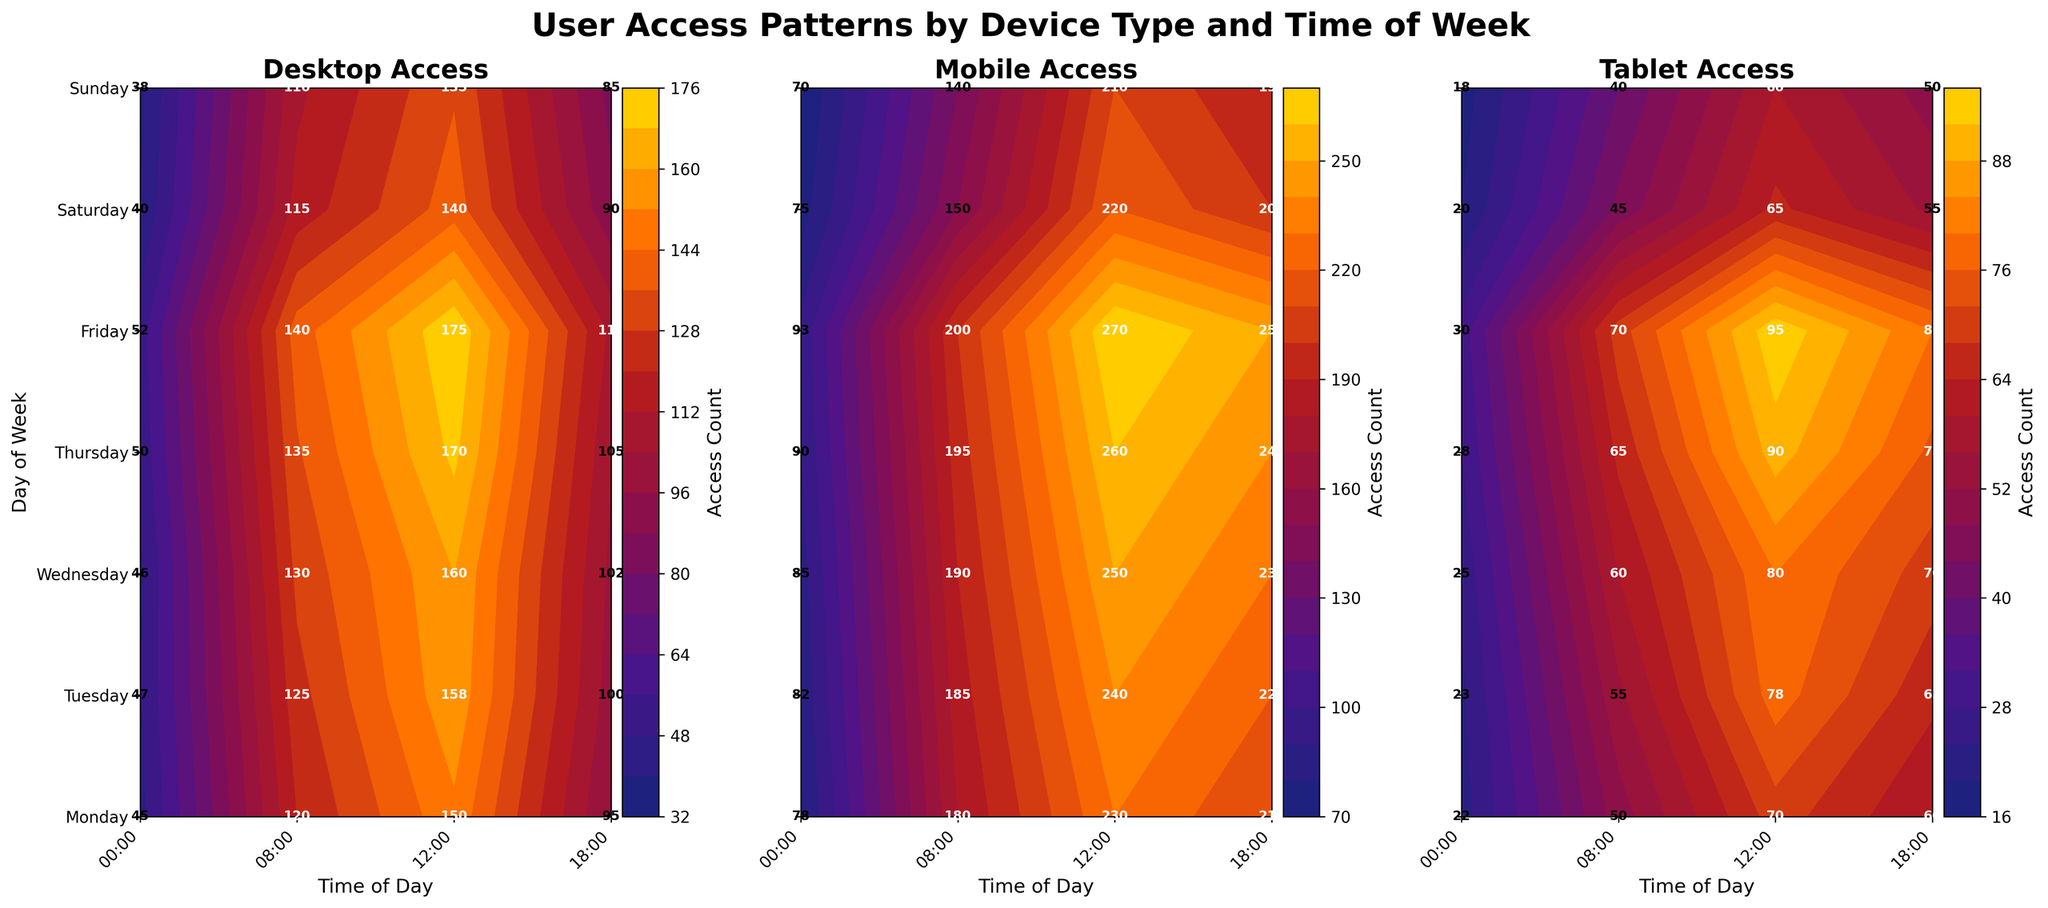What days of the week are displayed on the Y-axis? The Y-axis is labeled with the days of the week. By looking at the figure, we can see that each subplot has the days: Monday, Tuesday, Wednesday, Thursday, Friday, Saturday, and Sunday.
Answer: Monday, Tuesday, Wednesday, Thursday, Friday, Saturday, Sunday What times of the day are displayed on the X-axis? The X-axis is labeled with the times of the day. By looking at the figure, we can see that each subplot has the times: 00:00, 08:00, 12:00, and 18:00.
Answer: 00:00, 08:00, 12:00, 18:00 Which device has the highest total access count on Monday? To answer this, we need to sum up the access counts for each device on Monday. For the Desktop, the counts are 45, 120, 150, 95 which sum up to 410. For the Mobile, the counts are 78, 180, 230, 210 which sum up to 698. For the Tablet, the counts are 22, 50, 70, 60 which sum up to 202. Mobile has the highest total access count.
Answer: Mobile What is the access count for Mobile devices at 12:00 on Wednesday? By looking at the "Mobile Access" subplot and locating the point where Wednesday and 12:00 intersect, we can see the access count is 250.
Answer: 250 Which device type saw the lowest access count at 00:00 on Sunday? By looking at the three subplots and locating the point where Sunday and 00:00 intersect in each, we can see the access counts are: Desktop - 38, Mobile - 70, Tablet - 18. Tablet has the lowest access count.
Answer: Tablet What is the range of access counts for Tablet devices on Thursday? The access counts for Tablet devices on Thursday at different times are 28 (00:00), 65 (08:00), 90 (12:00), and 75 (18:00). The range is calculated as the maximum value minus the minimum value: 90 - 28 = 62.
Answer: 62 How does the access pattern for Mobile devices on Friday at 12:00 compare to Desktop and Tablet devices at the same time? By looking at the three subplots, at 12:00 on Friday, we see the access counts are: Desktop - 175, Mobile - 270, Tablet - 95. Mobile has the highest access count, followed by Desktop, and then Tablet.
Answer: Mobile > Desktop > Tablet What pattern can be observed for Desktop accesses over the week at 08:00? By looking at the "Desktop Access" subplot and observing the line corresponding to 08:00, we notice that the access counts gradually increase from Monday to Friday and then drop on Saturday and Sunday. Specifically: Monday - 120, Tuesday - 125, Wednesday - 130, Thursday - 135, Friday - 140, Saturday - 115, Sunday - 110.
Answer: Increase from Mon to Fri, drop on Sat and Sun Is there any time where all three device types have a similar access count? If so, when is it? By comparing the three subplots, we can look for a time slot where the access counts are similar. At 08:00 on Sunday, the access counts are: Desktop - 110, Mobile - 140, Tablet - 40. Although the Tablet count is distinctly lower, the Desktop and Mobile counts are relatively close. This pattern is generally not common across the three devices.
Answer: No consistent pattern across all three devices 